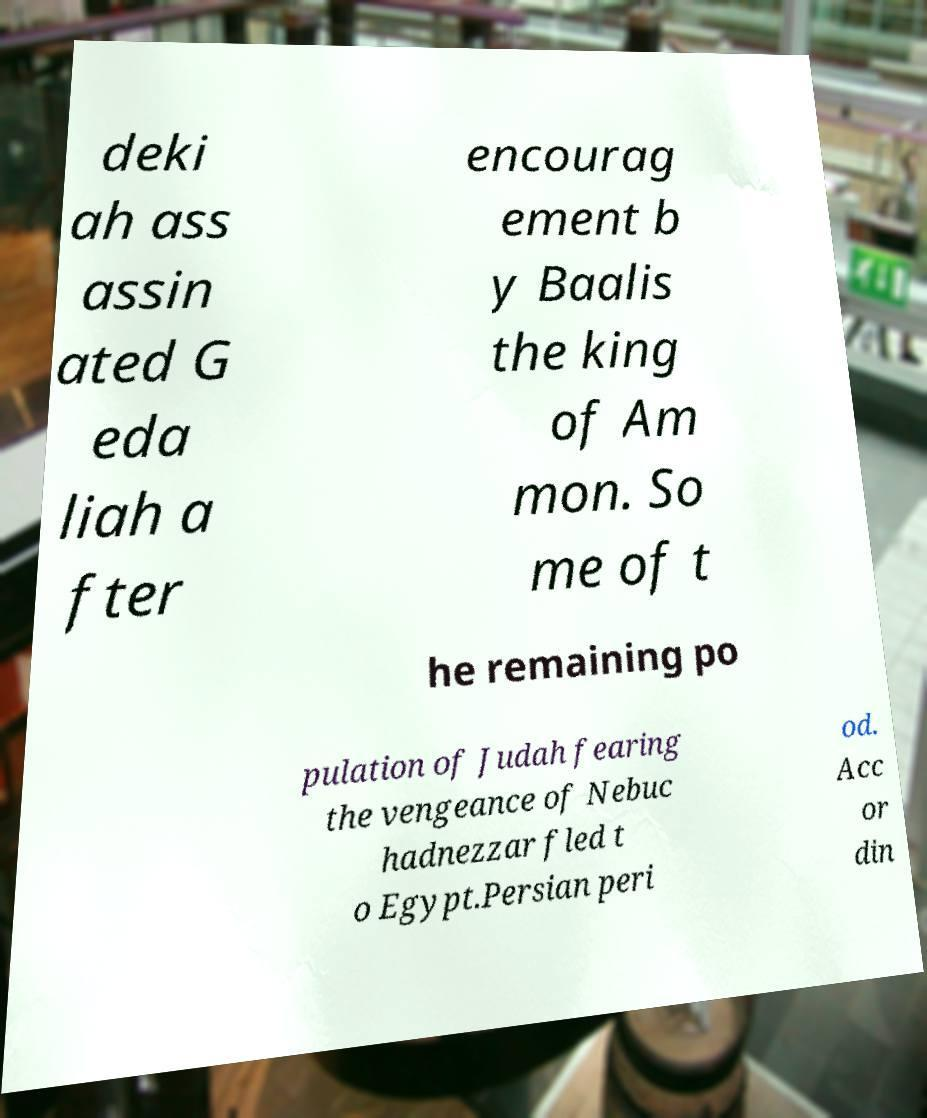Please read and relay the text visible in this image. What does it say? deki ah ass assin ated G eda liah a fter encourag ement b y Baalis the king of Am mon. So me of t he remaining po pulation of Judah fearing the vengeance of Nebuc hadnezzar fled t o Egypt.Persian peri od. Acc or din 